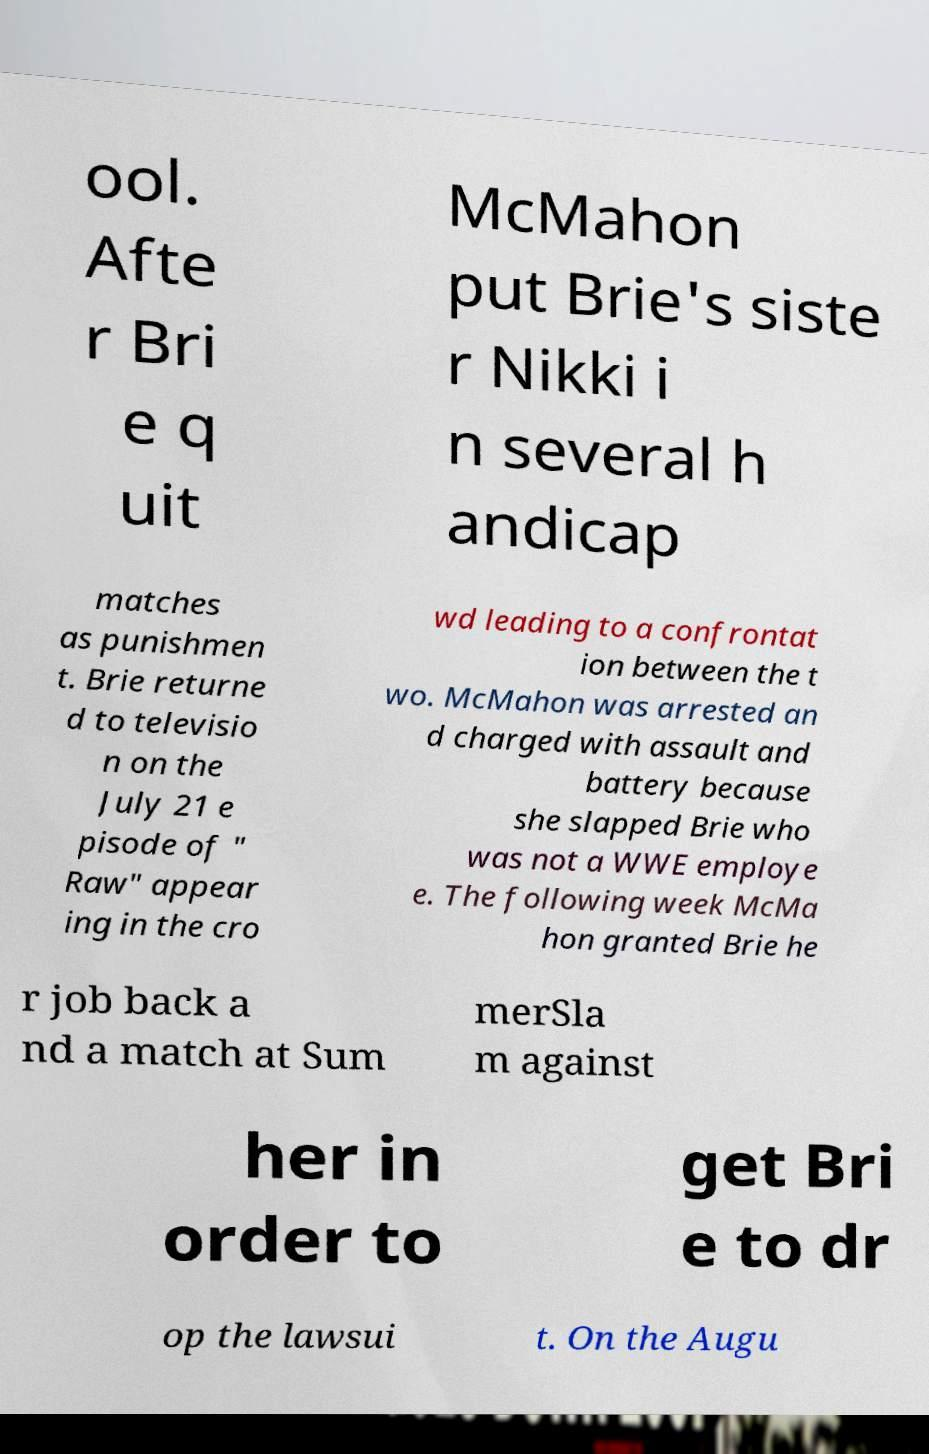Please read and relay the text visible in this image. What does it say? ool. Afte r Bri e q uit McMahon put Brie's siste r Nikki i n several h andicap matches as punishmen t. Brie returne d to televisio n on the July 21 e pisode of " Raw" appear ing in the cro wd leading to a confrontat ion between the t wo. McMahon was arrested an d charged with assault and battery because she slapped Brie who was not a WWE employe e. The following week McMa hon granted Brie he r job back a nd a match at Sum merSla m against her in order to get Bri e to dr op the lawsui t. On the Augu 